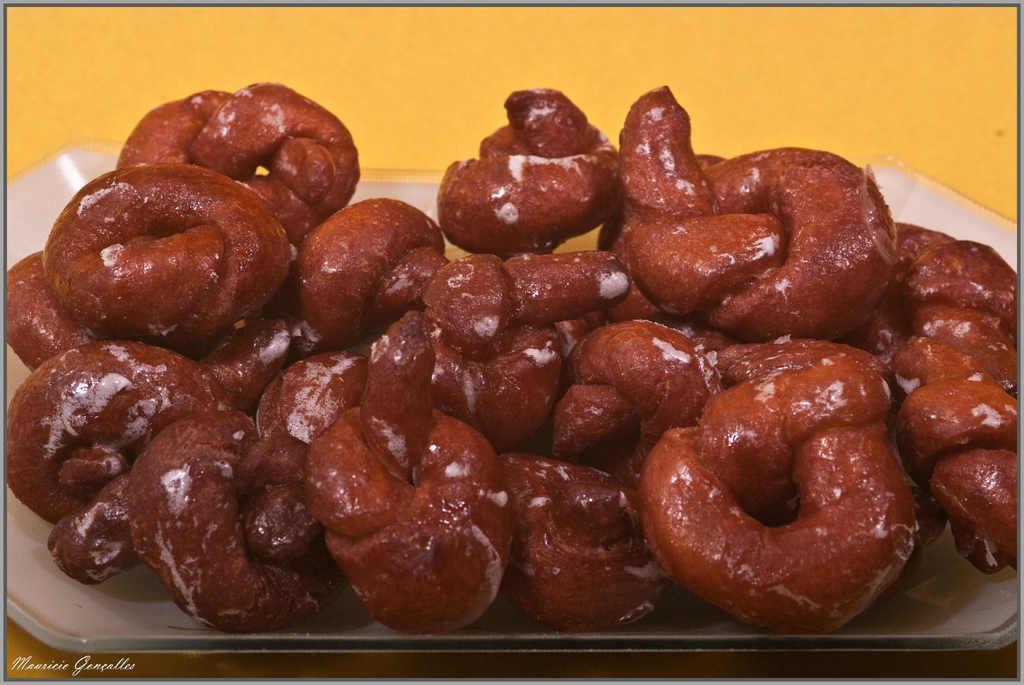Please provide a concise description of this image. In the foreground of this image, it seems like pretzel on a white tray which is on a yellow surface. 